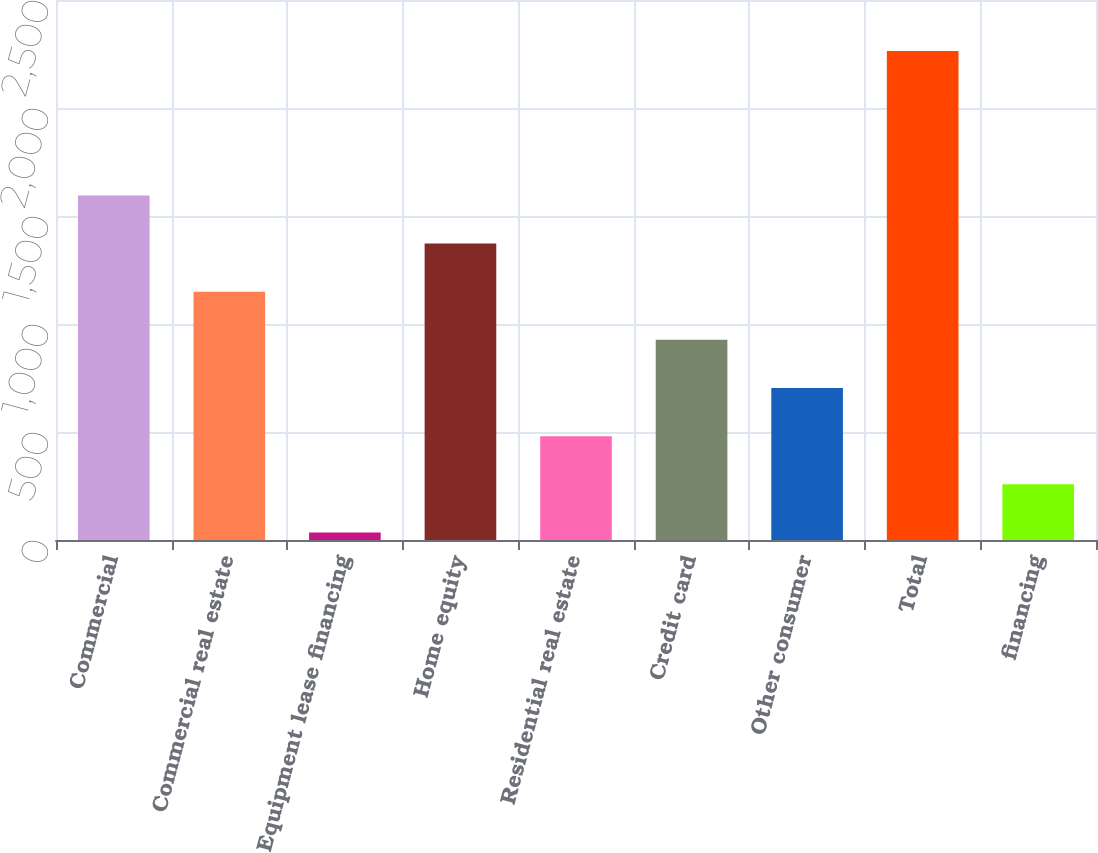Convert chart to OTSL. <chart><loc_0><loc_0><loc_500><loc_500><bar_chart><fcel>Commercial<fcel>Commercial real estate<fcel>Equipment lease financing<fcel>Home equity<fcel>Residential real estate<fcel>Credit card<fcel>Other consumer<fcel>Total<fcel>financing<nl><fcel>1595.3<fcel>1149.5<fcel>35<fcel>1372.4<fcel>480.8<fcel>926.6<fcel>703.7<fcel>2264<fcel>257.9<nl></chart> 